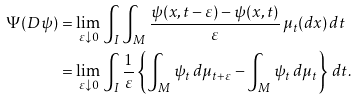<formula> <loc_0><loc_0><loc_500><loc_500>\Psi ( D \psi ) & = \lim _ { \varepsilon \downarrow 0 } \int _ { I } \int _ { M } \frac { \psi ( x , t - \varepsilon ) - \psi ( x , t ) } { \varepsilon } \, \mu _ { t } ( d x ) \, d t \\ & = \lim _ { \varepsilon \downarrow 0 } \int _ { I } \frac { 1 } { \varepsilon } \left \{ \int _ { M } \psi _ { t } \, d \mu _ { t + \varepsilon } - \int _ { M } \psi _ { t } \, d \mu _ { t } \right \} \, d t .</formula> 